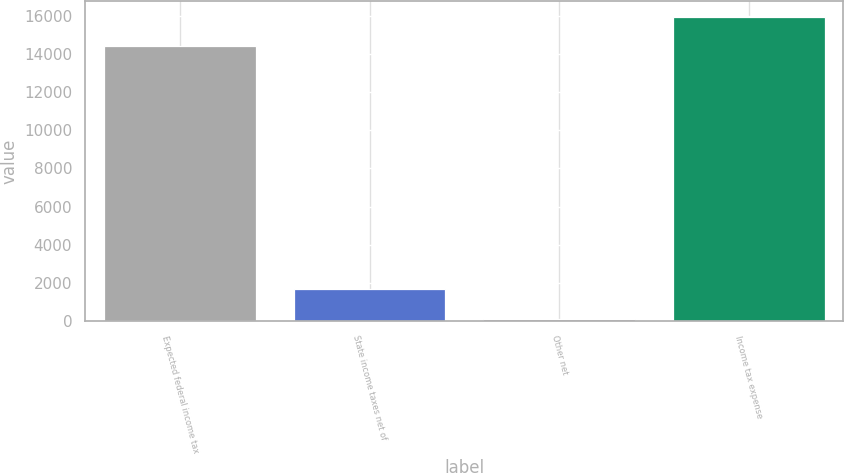Convert chart to OTSL. <chart><loc_0><loc_0><loc_500><loc_500><bar_chart><fcel>Expected federal income tax<fcel>State income taxes net of<fcel>Other net<fcel>Income tax expense<nl><fcel>14398<fcel>1674.7<fcel>124<fcel>15948.7<nl></chart> 